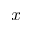Convert formula to latex. <formula><loc_0><loc_0><loc_500><loc_500>x</formula> 